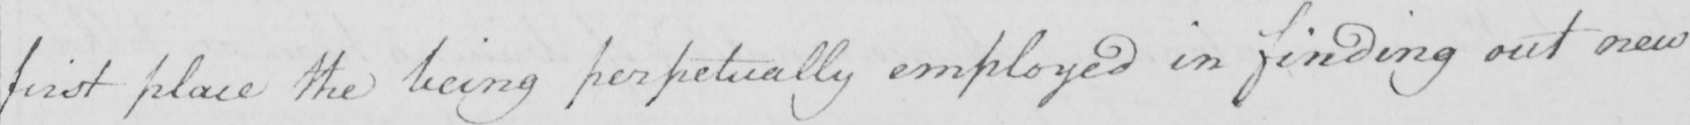What does this handwritten line say? first place the being perpetually employed in finding out new 